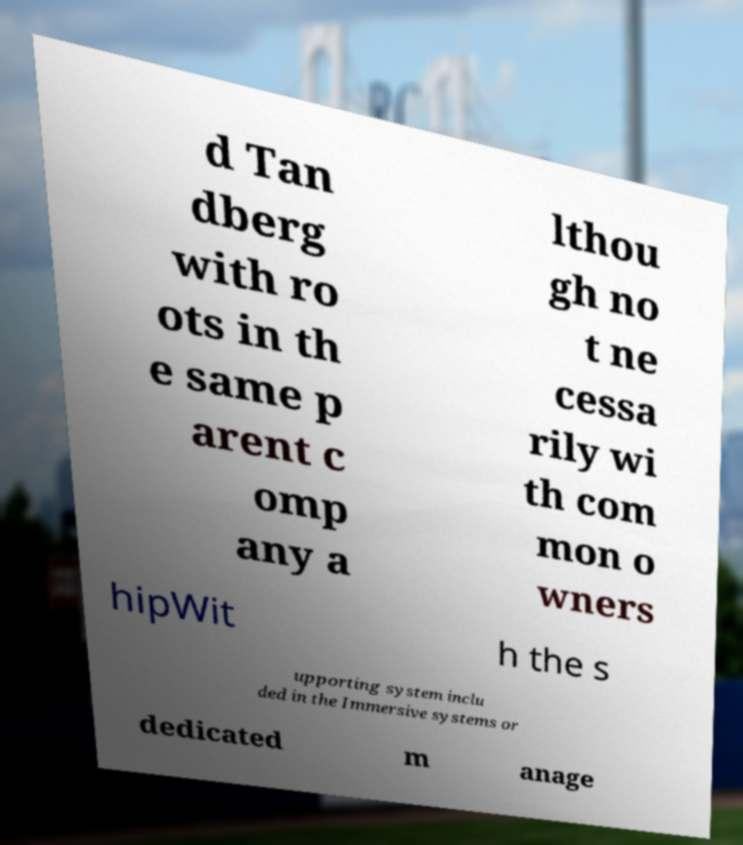Could you assist in decoding the text presented in this image and type it out clearly? d Tan dberg with ro ots in th e same p arent c omp any a lthou gh no t ne cessa rily wi th com mon o wners hipWit h the s upporting system inclu ded in the Immersive systems or dedicated m anage 